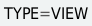Convert code to text. <code><loc_0><loc_0><loc_500><loc_500><_VisualBasic_>TYPE=VIEW</code> 